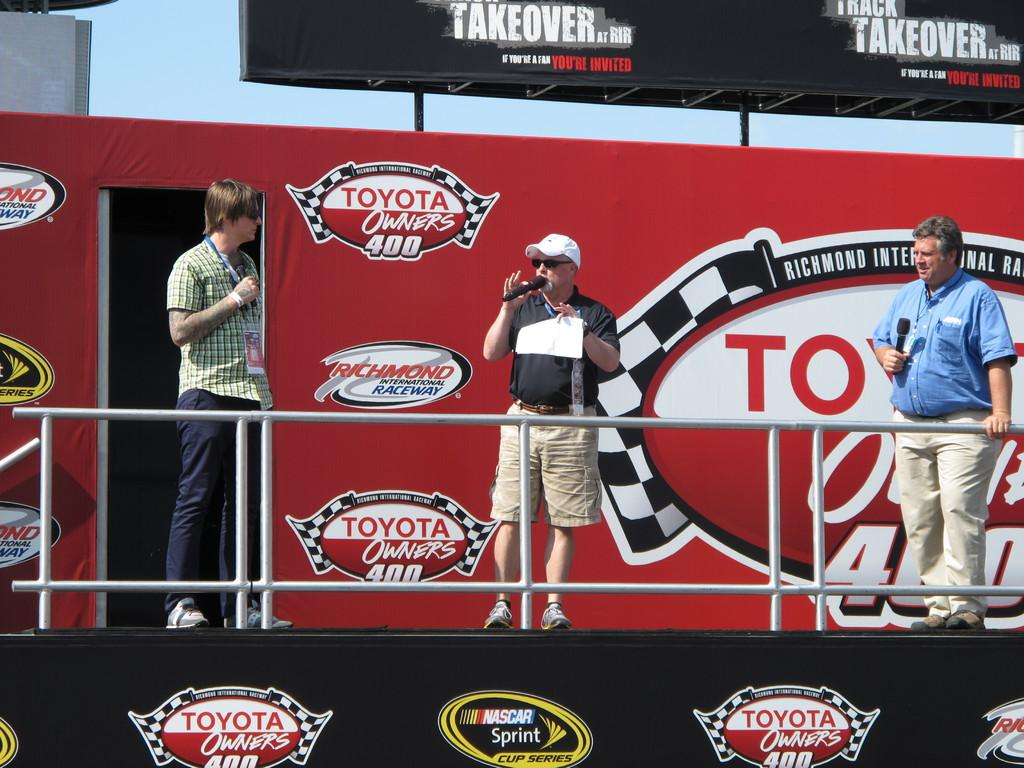<image>
Summarize the visual content of the image. A man is speaking on a stage that says Nascar. 